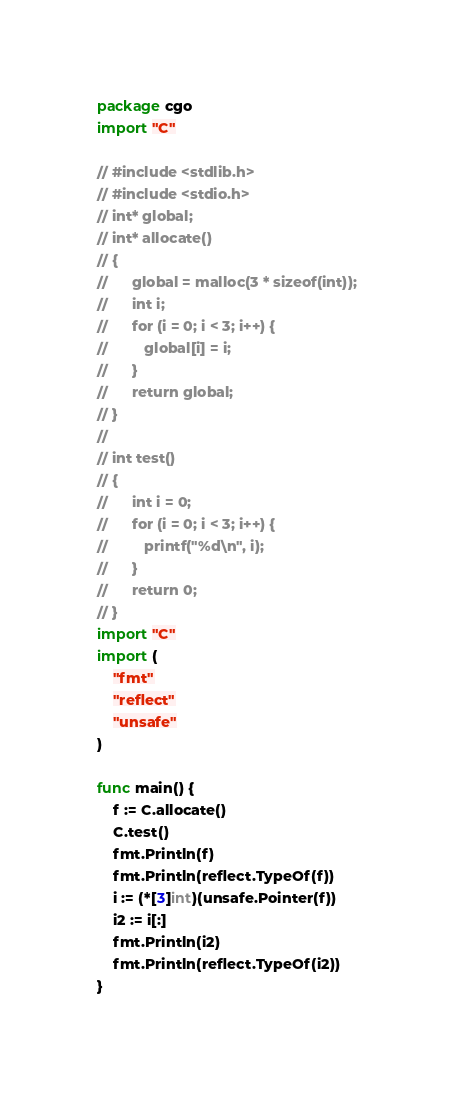Convert code to text. <code><loc_0><loc_0><loc_500><loc_500><_Go_>package cgo
import "C"

// #include <stdlib.h>
// #include <stdio.h>
// int* global;
// int* allocate()
// {
//	    global = malloc(3 * sizeof(int));
//      int i;
//      for (i = 0; i < 3; i++) {
//         global[i] = i;
//      }
//      return global;
// }
//
// int test()
// {
//      int i = 0;
//      for (i = 0; i < 3; i++) {
//         printf("%d\n", i);
//      }
//      return 0;
// }
import "C"
import (
	"fmt"
	"reflect"
	"unsafe"
)

func main() {
	f := C.allocate()
	C.test()
	fmt.Println(f)
	fmt.Println(reflect.TypeOf(f))
	i := (*[3]int)(unsafe.Pointer(f))
	i2 := i[:]
	fmt.Println(i2)
	fmt.Println(reflect.TypeOf(i2))
}</code> 